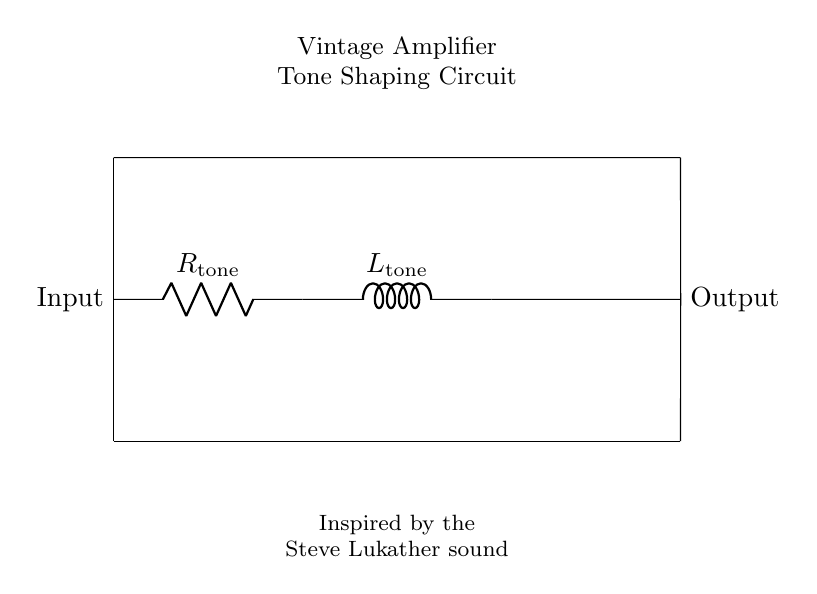What is the first component in the circuit? The first component listed in the circuit is a resistor labeled as R tone, which is positioned between the input and the inductor.
Answer: R tone What does L tone represent in the circuit? L tone represents the inductor in the circuit, which is connected in series after the resistor R tone.
Answer: Inductor How many components are in series in this circuit? There are two components in series in this circuit: the resistor R tone and the inductor L tone.
Answer: Two What is the purpose of this circuit? The purpose of the circuit is for tone shaping in vintage amplifiers, which is indicated in the label above the diagram.
Answer: Tone shaping Which component affects the frequency response in the circuit? The inductor L tone affects the frequency response of the circuit, as inductors play a key role in filtering and tone shaping.
Answer: Inductor L tone How does the resistor influence the circuit? The resistor R tone influences the circuit by altering the total impedance and therefore affecting the tone and volume of the output signal.
Answer: Alters impedance Which side of the circuit is the input? The left side of the circuit is the input side, as indicated by the label "Input" placed next to it.
Answer: Left side 